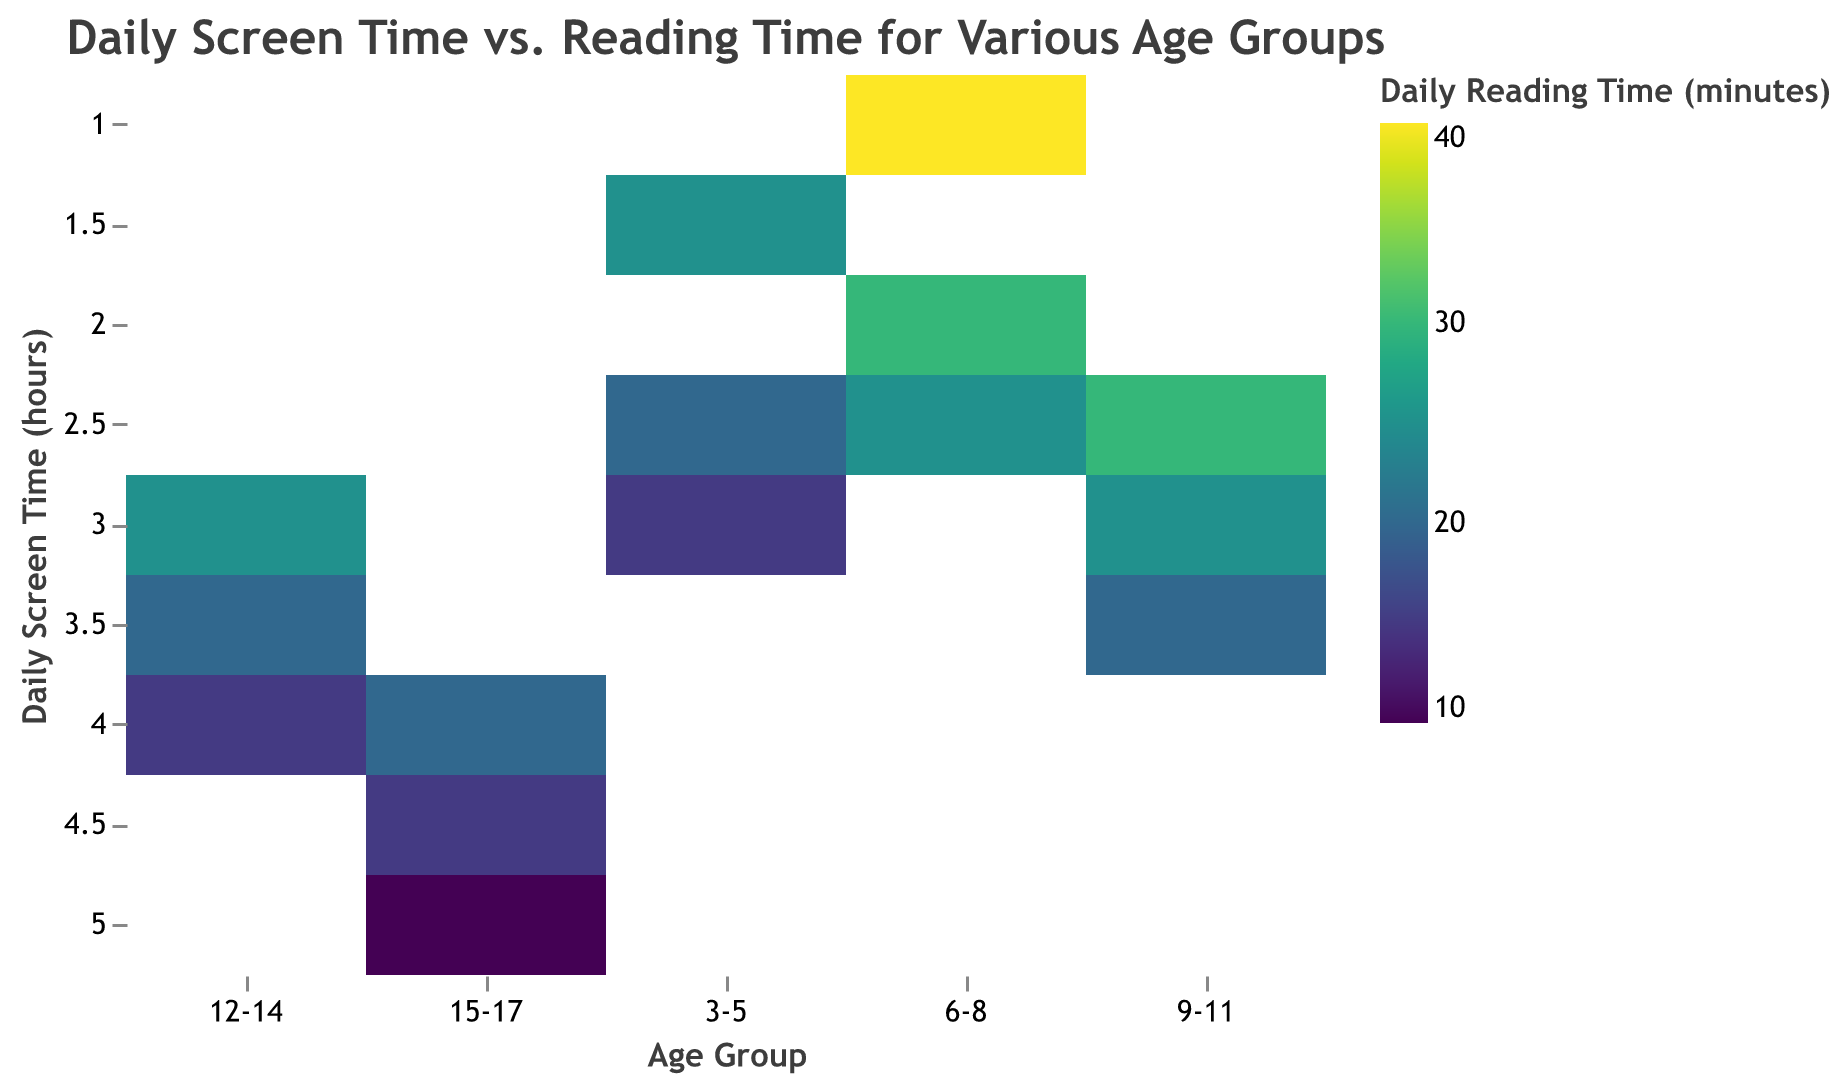What is the title of the heatmap? The title is typically located at the top of the figure and describes the main content.
Answer: Daily Screen Time vs. Reading Time for Various Age Groups Which age group has the highest daily screen time, and what is that value? The y-axis represents daily screen time, and the age groups are on the x-axis. The highest value along the y-axis for any age group is 5.0 hours for age group 15-17.
Answer: 15-17, 5.0 hours What color does the data point for age group 3-5 with 2.5 hours of daily screen time have? To find this, locate the age group 3-5 on the x-axis and 2.5 hours on the y-axis. The corresponding color represents the daily reading time (20 minutes) and should be found from the color legend using the viridis color scheme.
Answer: The color corresponding to 20 minutes, as per the viridis color scheme How does daily reading time change from age group 3-5 to 6-8 for 2.5 hours of screen time? For 2.5 hours of screen time, compare the reading times for age groups 3-5 and 6-8 by checking the colors for those cells and cross-referencing them with the legend.
Answer: 3-5: 20 minutes, 6-8: 25 minutes What is the range of daily reading times observed for age group 6-8 across all screen times? Check all the data points for the age group 6-8 along the x-axis and observe how daily reading times vary using the color legend. The values range from 25 to 40 minutes.
Answer: 25 to 40 minutes Which age group has the lowest daily reading time for 3.0 hours of screen time, and what is that value? Locate the column for 3.0 hours of screen time, then look at the color shade for all age groups and match them with the legend to find the exact reading time for each age group. The lowest value for 3.0 hours of screen time is in age group 3-5, with 15 minutes.
Answer: 3-5, 15 minutes Is there an inverse relationship between daily screen time and daily reading time for any particular age group? Check the color gradient along the y-axis (screen time) for each age group on the x-axis. An inverse relationship would show darker (higher reading time) to lighter (lower reading time) hues as screen time increases. The age group 15-17 shows this pattern where reading time decreases as screen time increases.
Answer: Yes, for the age group 15-17 What is the average daily reading time for the age group 9-11 across all screen time values? Sum all reading times for 9-11, which are 20, 25, and 30 minutes: 20 + 25 + 30 = 75 minutes. Then divide by the number of data points (3): 75/3 = 25 minutes.
Answer: 25 minutes 